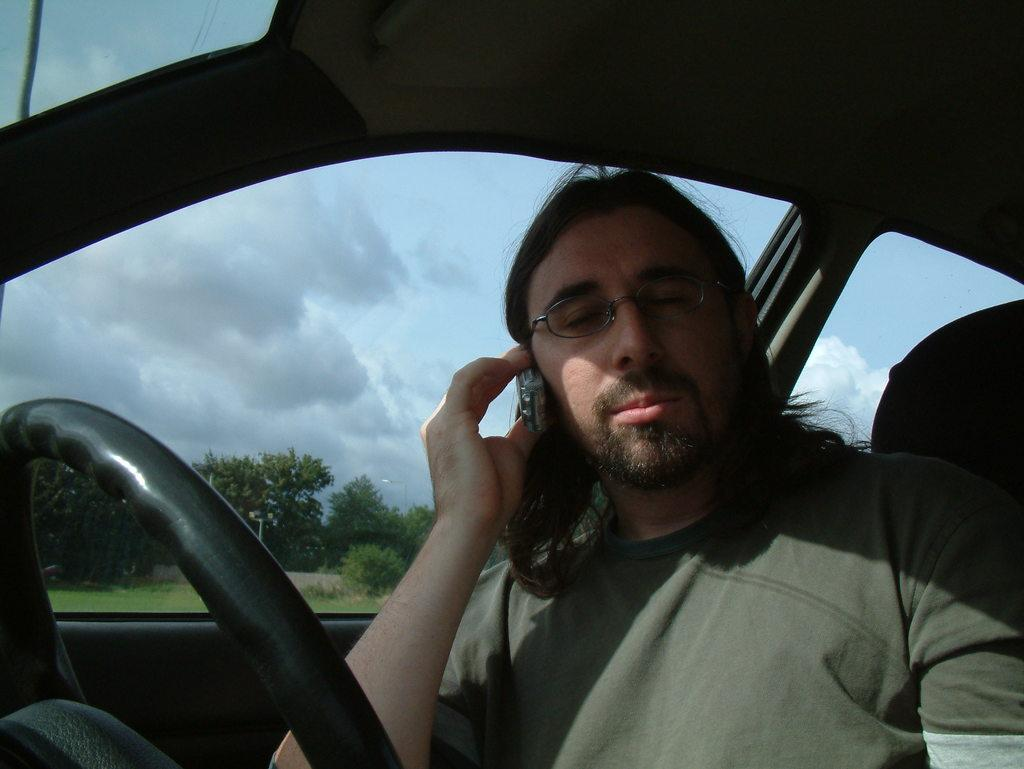What is the person in the image doing? The person is holding a mobile phone and wearing goggles. Where is the person located in the image? The person is sitting in a car. What can be seen in the background of the image? There are trees and a pole in the image. What is visible in the sky in the image? There are clouds in the sky. What type of club does the person use to hit the ball in the image? There is no ball or club present in the image. What muscle is the person exercising while sitting in the car? The person is sitting in the car and not exercising any muscles in the image. 